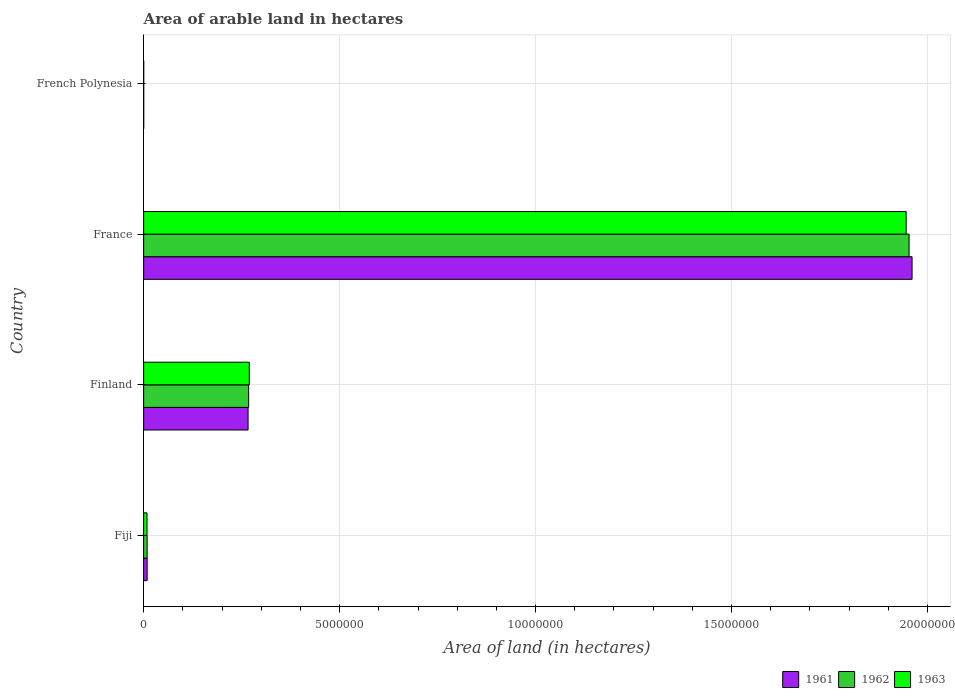How many groups of bars are there?
Your answer should be very brief. 4. Are the number of bars per tick equal to the number of legend labels?
Offer a terse response. Yes. Are the number of bars on each tick of the Y-axis equal?
Your response must be concise. Yes. How many bars are there on the 2nd tick from the top?
Offer a terse response. 3. What is the label of the 4th group of bars from the top?
Ensure brevity in your answer.  Fiji. Across all countries, what is the maximum total arable land in 1963?
Your answer should be compact. 1.95e+07. In which country was the total arable land in 1963 maximum?
Provide a short and direct response. France. In which country was the total arable land in 1962 minimum?
Your answer should be compact. French Polynesia. What is the total total arable land in 1961 in the graph?
Your answer should be compact. 2.24e+07. What is the difference between the total arable land in 1961 in Finland and that in French Polynesia?
Your answer should be compact. 2.66e+06. What is the difference between the total arable land in 1962 in Finland and the total arable land in 1963 in France?
Make the answer very short. -1.68e+07. What is the average total arable land in 1962 per country?
Provide a succinct answer. 5.58e+06. What is the difference between the total arable land in 1963 and total arable land in 1961 in Finland?
Make the answer very short. 3.08e+04. What is the ratio of the total arable land in 1963 in Fiji to that in France?
Your response must be concise. 0. Is the total arable land in 1963 in Fiji less than that in Finland?
Provide a succinct answer. Yes. Is the difference between the total arable land in 1963 in Fiji and French Polynesia greater than the difference between the total arable land in 1961 in Fiji and French Polynesia?
Provide a short and direct response. No. What is the difference between the highest and the second highest total arable land in 1963?
Give a very brief answer. 1.68e+07. What is the difference between the highest and the lowest total arable land in 1961?
Provide a short and direct response. 1.96e+07. Is the sum of the total arable land in 1962 in Finland and French Polynesia greater than the maximum total arable land in 1963 across all countries?
Offer a terse response. No. What does the 1st bar from the bottom in Finland represents?
Keep it short and to the point. 1961. Is it the case that in every country, the sum of the total arable land in 1963 and total arable land in 1961 is greater than the total arable land in 1962?
Provide a short and direct response. Yes. How many countries are there in the graph?
Provide a short and direct response. 4. Does the graph contain any zero values?
Offer a very short reply. No. Does the graph contain grids?
Provide a succinct answer. Yes. Where does the legend appear in the graph?
Your answer should be very brief. Bottom right. How many legend labels are there?
Keep it short and to the point. 3. What is the title of the graph?
Offer a terse response. Area of arable land in hectares. Does "1967" appear as one of the legend labels in the graph?
Make the answer very short. No. What is the label or title of the X-axis?
Give a very brief answer. Area of land (in hectares). What is the Area of land (in hectares) in 1961 in Fiji?
Provide a succinct answer. 8.90e+04. What is the Area of land (in hectares) in 1962 in Fiji?
Offer a very short reply. 8.90e+04. What is the Area of land (in hectares) in 1963 in Fiji?
Offer a terse response. 8.60e+04. What is the Area of land (in hectares) of 1961 in Finland?
Your answer should be very brief. 2.66e+06. What is the Area of land (in hectares) in 1962 in Finland?
Ensure brevity in your answer.  2.68e+06. What is the Area of land (in hectares) in 1963 in Finland?
Ensure brevity in your answer.  2.70e+06. What is the Area of land (in hectares) of 1961 in France?
Ensure brevity in your answer.  1.96e+07. What is the Area of land (in hectares) in 1962 in France?
Ensure brevity in your answer.  1.95e+07. What is the Area of land (in hectares) in 1963 in France?
Provide a succinct answer. 1.95e+07. Across all countries, what is the maximum Area of land (in hectares) of 1961?
Your answer should be very brief. 1.96e+07. Across all countries, what is the maximum Area of land (in hectares) of 1962?
Ensure brevity in your answer.  1.95e+07. Across all countries, what is the maximum Area of land (in hectares) of 1963?
Provide a succinct answer. 1.95e+07. What is the total Area of land (in hectares) of 1961 in the graph?
Keep it short and to the point. 2.24e+07. What is the total Area of land (in hectares) in 1962 in the graph?
Give a very brief answer. 2.23e+07. What is the total Area of land (in hectares) in 1963 in the graph?
Offer a very short reply. 2.22e+07. What is the difference between the Area of land (in hectares) in 1961 in Fiji and that in Finland?
Provide a succinct answer. -2.58e+06. What is the difference between the Area of land (in hectares) in 1962 in Fiji and that in Finland?
Keep it short and to the point. -2.59e+06. What is the difference between the Area of land (in hectares) in 1963 in Fiji and that in Finland?
Provide a short and direct response. -2.61e+06. What is the difference between the Area of land (in hectares) in 1961 in Fiji and that in France?
Your answer should be very brief. -1.95e+07. What is the difference between the Area of land (in hectares) of 1962 in Fiji and that in France?
Your answer should be very brief. -1.94e+07. What is the difference between the Area of land (in hectares) of 1963 in Fiji and that in France?
Your answer should be very brief. -1.94e+07. What is the difference between the Area of land (in hectares) in 1961 in Fiji and that in French Polynesia?
Your response must be concise. 8.70e+04. What is the difference between the Area of land (in hectares) in 1962 in Fiji and that in French Polynesia?
Ensure brevity in your answer.  8.70e+04. What is the difference between the Area of land (in hectares) in 1963 in Fiji and that in French Polynesia?
Ensure brevity in your answer.  8.40e+04. What is the difference between the Area of land (in hectares) in 1961 in Finland and that in France?
Offer a very short reply. -1.69e+07. What is the difference between the Area of land (in hectares) in 1962 in Finland and that in France?
Keep it short and to the point. -1.69e+07. What is the difference between the Area of land (in hectares) of 1963 in Finland and that in France?
Your response must be concise. -1.68e+07. What is the difference between the Area of land (in hectares) of 1961 in Finland and that in French Polynesia?
Your answer should be very brief. 2.66e+06. What is the difference between the Area of land (in hectares) in 1962 in Finland and that in French Polynesia?
Your answer should be very brief. 2.68e+06. What is the difference between the Area of land (in hectares) in 1963 in Finland and that in French Polynesia?
Provide a succinct answer. 2.69e+06. What is the difference between the Area of land (in hectares) in 1961 in France and that in French Polynesia?
Provide a succinct answer. 1.96e+07. What is the difference between the Area of land (in hectares) of 1962 in France and that in French Polynesia?
Ensure brevity in your answer.  1.95e+07. What is the difference between the Area of land (in hectares) in 1963 in France and that in French Polynesia?
Offer a very short reply. 1.95e+07. What is the difference between the Area of land (in hectares) of 1961 in Fiji and the Area of land (in hectares) of 1962 in Finland?
Offer a very short reply. -2.59e+06. What is the difference between the Area of land (in hectares) of 1961 in Fiji and the Area of land (in hectares) of 1963 in Finland?
Your answer should be very brief. -2.61e+06. What is the difference between the Area of land (in hectares) of 1962 in Fiji and the Area of land (in hectares) of 1963 in Finland?
Make the answer very short. -2.61e+06. What is the difference between the Area of land (in hectares) in 1961 in Fiji and the Area of land (in hectares) in 1962 in France?
Your answer should be very brief. -1.94e+07. What is the difference between the Area of land (in hectares) in 1961 in Fiji and the Area of land (in hectares) in 1963 in France?
Ensure brevity in your answer.  -1.94e+07. What is the difference between the Area of land (in hectares) in 1962 in Fiji and the Area of land (in hectares) in 1963 in France?
Your answer should be very brief. -1.94e+07. What is the difference between the Area of land (in hectares) of 1961 in Fiji and the Area of land (in hectares) of 1962 in French Polynesia?
Your answer should be very brief. 8.70e+04. What is the difference between the Area of land (in hectares) of 1961 in Fiji and the Area of land (in hectares) of 1963 in French Polynesia?
Give a very brief answer. 8.70e+04. What is the difference between the Area of land (in hectares) of 1962 in Fiji and the Area of land (in hectares) of 1963 in French Polynesia?
Your answer should be very brief. 8.70e+04. What is the difference between the Area of land (in hectares) of 1961 in Finland and the Area of land (in hectares) of 1962 in France?
Keep it short and to the point. -1.69e+07. What is the difference between the Area of land (in hectares) in 1961 in Finland and the Area of land (in hectares) in 1963 in France?
Your answer should be compact. -1.68e+07. What is the difference between the Area of land (in hectares) in 1962 in Finland and the Area of land (in hectares) in 1963 in France?
Your response must be concise. -1.68e+07. What is the difference between the Area of land (in hectares) in 1961 in Finland and the Area of land (in hectares) in 1962 in French Polynesia?
Your answer should be compact. 2.66e+06. What is the difference between the Area of land (in hectares) in 1961 in Finland and the Area of land (in hectares) in 1963 in French Polynesia?
Your response must be concise. 2.66e+06. What is the difference between the Area of land (in hectares) of 1962 in Finland and the Area of land (in hectares) of 1963 in French Polynesia?
Your answer should be very brief. 2.68e+06. What is the difference between the Area of land (in hectares) of 1961 in France and the Area of land (in hectares) of 1962 in French Polynesia?
Your answer should be very brief. 1.96e+07. What is the difference between the Area of land (in hectares) in 1961 in France and the Area of land (in hectares) in 1963 in French Polynesia?
Keep it short and to the point. 1.96e+07. What is the difference between the Area of land (in hectares) of 1962 in France and the Area of land (in hectares) of 1963 in French Polynesia?
Offer a very short reply. 1.95e+07. What is the average Area of land (in hectares) of 1961 per country?
Ensure brevity in your answer.  5.59e+06. What is the average Area of land (in hectares) in 1962 per country?
Your answer should be very brief. 5.58e+06. What is the average Area of land (in hectares) of 1963 per country?
Provide a short and direct response. 5.56e+06. What is the difference between the Area of land (in hectares) of 1961 and Area of land (in hectares) of 1963 in Fiji?
Give a very brief answer. 3000. What is the difference between the Area of land (in hectares) in 1962 and Area of land (in hectares) in 1963 in Fiji?
Keep it short and to the point. 3000. What is the difference between the Area of land (in hectares) in 1961 and Area of land (in hectares) in 1962 in Finland?
Provide a succinct answer. -1.44e+04. What is the difference between the Area of land (in hectares) in 1961 and Area of land (in hectares) in 1963 in Finland?
Provide a short and direct response. -3.08e+04. What is the difference between the Area of land (in hectares) in 1962 and Area of land (in hectares) in 1963 in Finland?
Keep it short and to the point. -1.64e+04. What is the difference between the Area of land (in hectares) in 1961 and Area of land (in hectares) in 1962 in France?
Make the answer very short. 7.60e+04. What is the difference between the Area of land (in hectares) in 1961 and Area of land (in hectares) in 1963 in France?
Your answer should be very brief. 1.51e+05. What is the difference between the Area of land (in hectares) of 1962 and Area of land (in hectares) of 1963 in France?
Your response must be concise. 7.50e+04. What is the difference between the Area of land (in hectares) in 1961 and Area of land (in hectares) in 1963 in French Polynesia?
Make the answer very short. 0. What is the ratio of the Area of land (in hectares) in 1961 in Fiji to that in Finland?
Ensure brevity in your answer.  0.03. What is the ratio of the Area of land (in hectares) in 1962 in Fiji to that in Finland?
Offer a very short reply. 0.03. What is the ratio of the Area of land (in hectares) in 1963 in Fiji to that in Finland?
Your response must be concise. 0.03. What is the ratio of the Area of land (in hectares) of 1961 in Fiji to that in France?
Provide a short and direct response. 0. What is the ratio of the Area of land (in hectares) in 1962 in Fiji to that in France?
Your response must be concise. 0. What is the ratio of the Area of land (in hectares) in 1963 in Fiji to that in France?
Keep it short and to the point. 0. What is the ratio of the Area of land (in hectares) of 1961 in Fiji to that in French Polynesia?
Your answer should be very brief. 44.5. What is the ratio of the Area of land (in hectares) in 1962 in Fiji to that in French Polynesia?
Keep it short and to the point. 44.5. What is the ratio of the Area of land (in hectares) in 1961 in Finland to that in France?
Make the answer very short. 0.14. What is the ratio of the Area of land (in hectares) of 1962 in Finland to that in France?
Your answer should be compact. 0.14. What is the ratio of the Area of land (in hectares) of 1963 in Finland to that in France?
Offer a terse response. 0.14. What is the ratio of the Area of land (in hectares) in 1961 in Finland to that in French Polynesia?
Your response must be concise. 1332.35. What is the ratio of the Area of land (in hectares) of 1962 in Finland to that in French Polynesia?
Ensure brevity in your answer.  1339.55. What is the ratio of the Area of land (in hectares) in 1963 in Finland to that in French Polynesia?
Offer a very short reply. 1347.75. What is the ratio of the Area of land (in hectares) of 1961 in France to that in French Polynesia?
Provide a short and direct response. 9803. What is the ratio of the Area of land (in hectares) of 1962 in France to that in French Polynesia?
Ensure brevity in your answer.  9765. What is the ratio of the Area of land (in hectares) in 1963 in France to that in French Polynesia?
Make the answer very short. 9727.5. What is the difference between the highest and the second highest Area of land (in hectares) in 1961?
Give a very brief answer. 1.69e+07. What is the difference between the highest and the second highest Area of land (in hectares) of 1962?
Make the answer very short. 1.69e+07. What is the difference between the highest and the second highest Area of land (in hectares) of 1963?
Ensure brevity in your answer.  1.68e+07. What is the difference between the highest and the lowest Area of land (in hectares) in 1961?
Make the answer very short. 1.96e+07. What is the difference between the highest and the lowest Area of land (in hectares) in 1962?
Your answer should be compact. 1.95e+07. What is the difference between the highest and the lowest Area of land (in hectares) of 1963?
Offer a very short reply. 1.95e+07. 